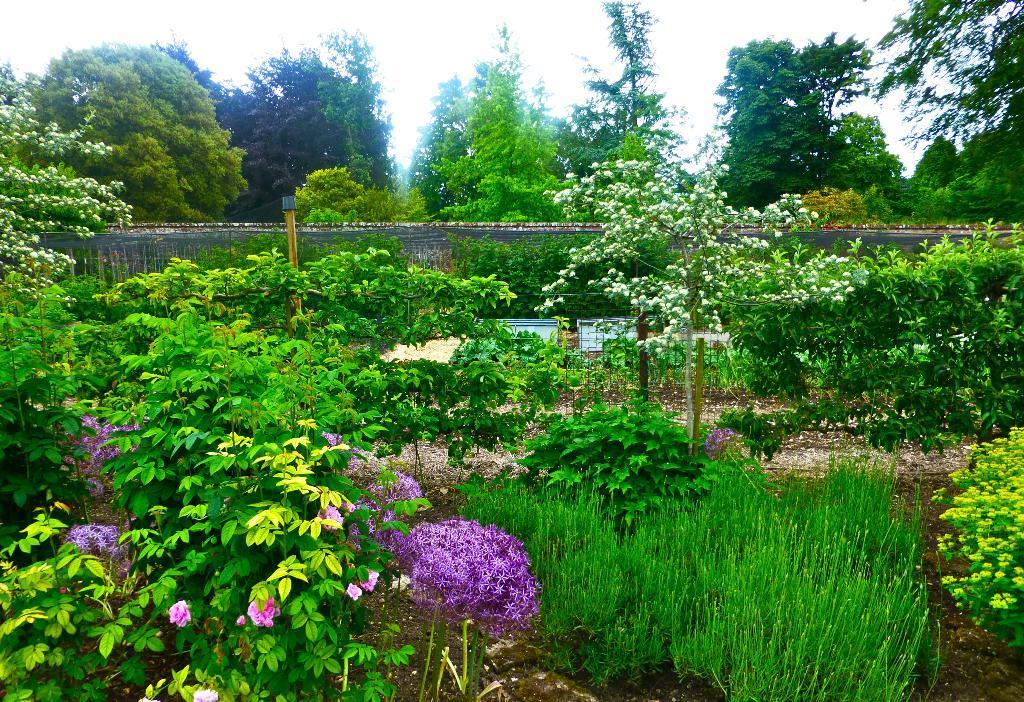Can you describe this image briefly? In this image I can see wall, pole, trees, plants, mesh, boards, flowers and sky. 